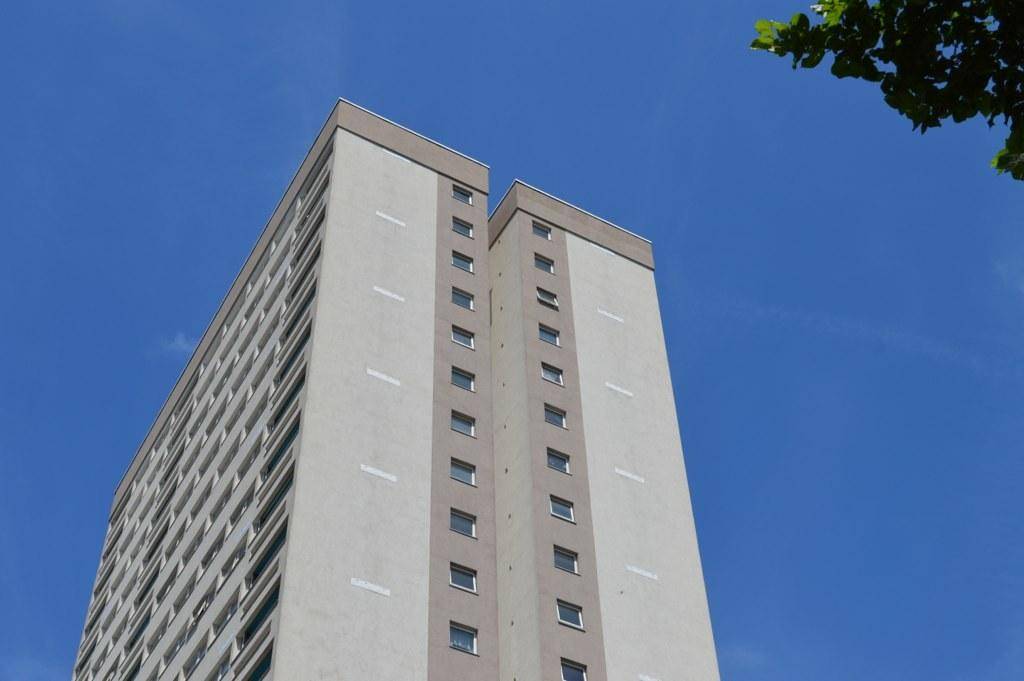What type of vegetation can be seen in the top right side of the image? There is a tree in the top right side of the image. What type of structure is located in the center of the image? There is a skyscraper in the center of the image. What type of thumb can be seen holding a pair of scissors in the image? There is no thumb or scissors present in the image. What type of bag is visible in the image? There is no bag present in the image. 